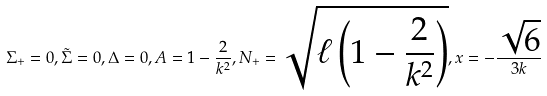<formula> <loc_0><loc_0><loc_500><loc_500>\Sigma _ { + } = 0 , \tilde { \Sigma } = 0 , \Delta = 0 , A = 1 - \frac { 2 } { k ^ { 2 } } , N _ { + } = \sqrt { \ell \left ( 1 - \frac { 2 } { k ^ { 2 } } \right ) } , x = - \frac { \sqrt { 6 } } { 3 k }</formula> 